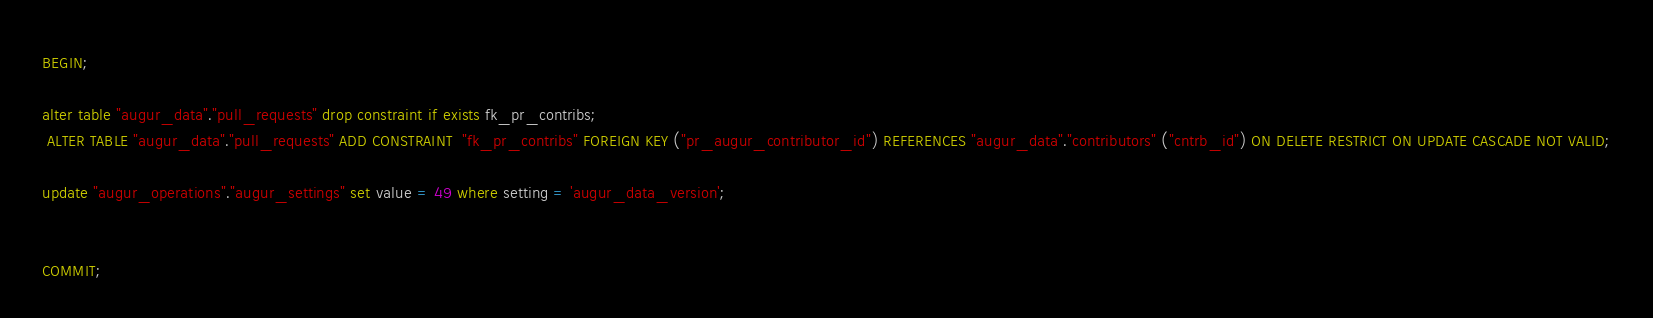Convert code to text. <code><loc_0><loc_0><loc_500><loc_500><_SQL_>
BEGIN;

alter table "augur_data"."pull_requests" drop constraint if exists fk_pr_contribs; 
 ALTER TABLE "augur_data"."pull_requests" ADD CONSTRAINT  "fk_pr_contribs" FOREIGN KEY ("pr_augur_contributor_id") REFERENCES "augur_data"."contributors" ("cntrb_id") ON DELETE RESTRICT ON UPDATE CASCADE NOT VALID;

update "augur_operations"."augur_settings" set value = 49 where setting = 'augur_data_version';


COMMIT; 

</code> 